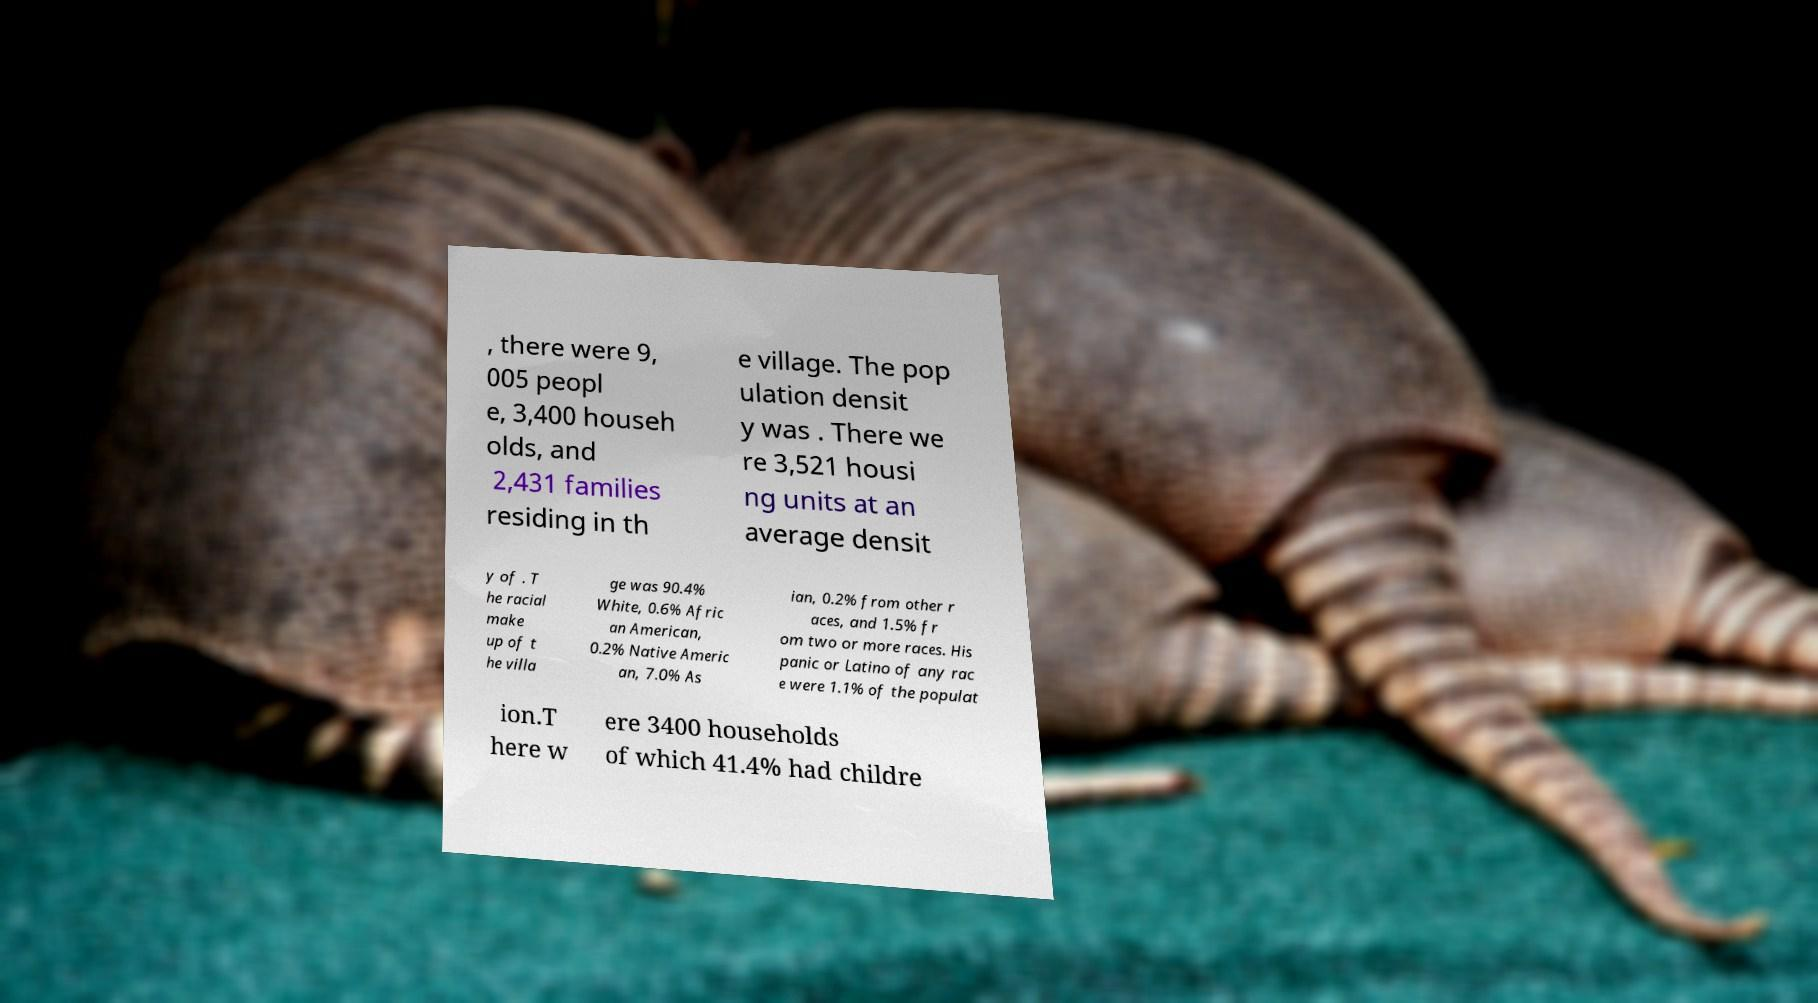I need the written content from this picture converted into text. Can you do that? , there were 9, 005 peopl e, 3,400 househ olds, and 2,431 families residing in th e village. The pop ulation densit y was . There we re 3,521 housi ng units at an average densit y of . T he racial make up of t he villa ge was 90.4% White, 0.6% Afric an American, 0.2% Native Americ an, 7.0% As ian, 0.2% from other r aces, and 1.5% fr om two or more races. His panic or Latino of any rac e were 1.1% of the populat ion.T here w ere 3400 households of which 41.4% had childre 